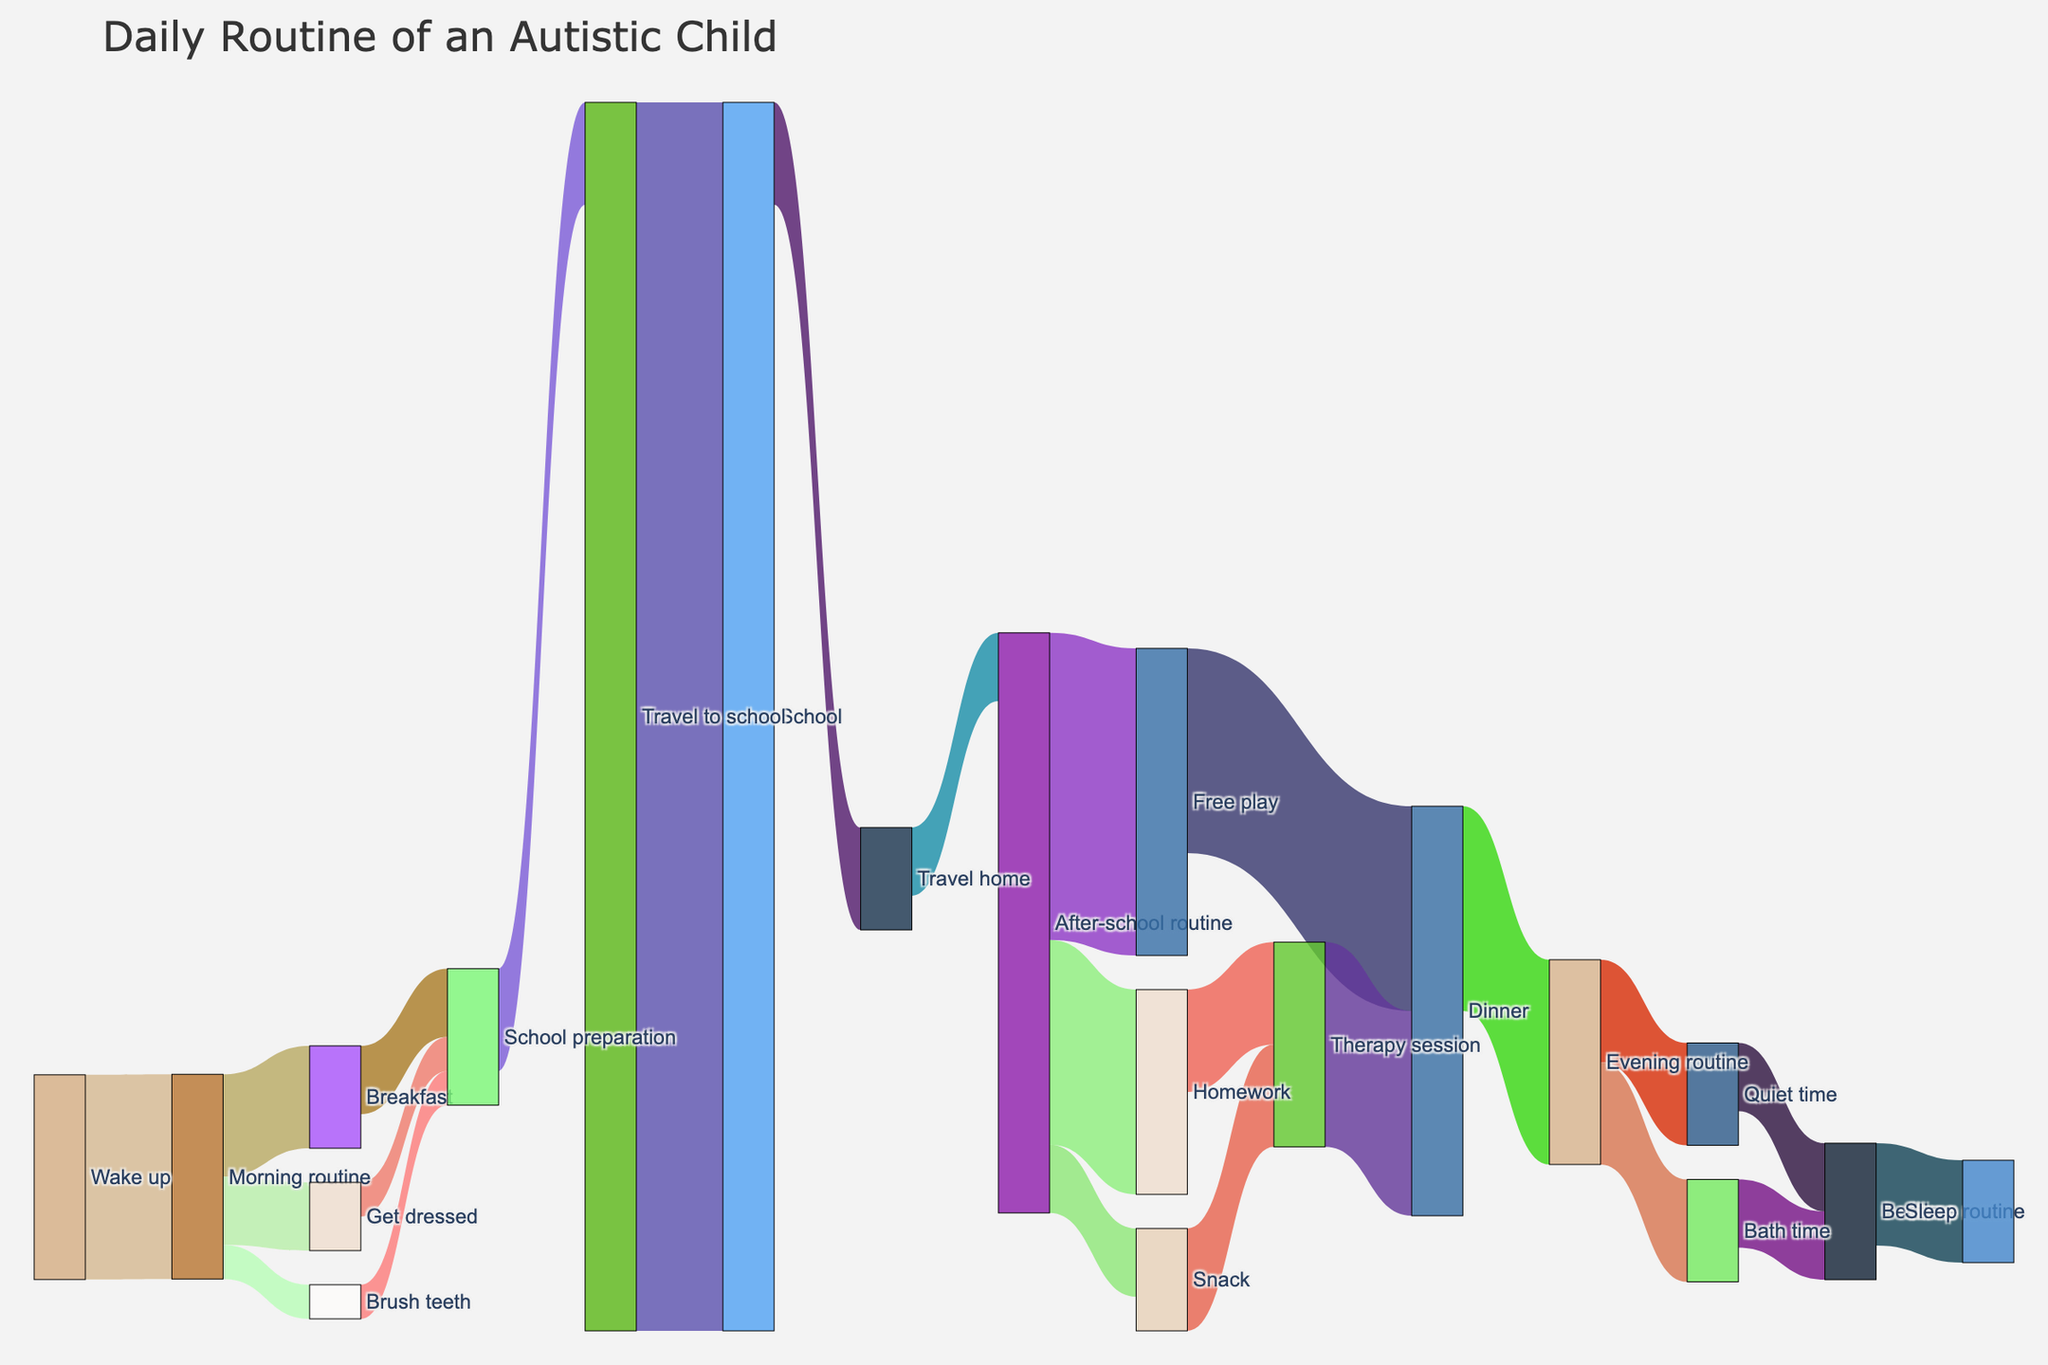What is the title of the figure? The title is at the top of the figure and provides an overview of what the figure represents.
Answer: Daily Routine of an Autistic Child How long is the duration of the Therapy session, and which activities transition into it? By observing the connections and the values indicated, you can see the activities and their corresponding time leading into the Therapy session.
Answer: Therapy session is 30 minutes, transitioning from Snack and Homework From which activity does 'Travel to school' originate and how long does it take? The diagram shows that 'Travel to school' originates from 'School preparation' with a specific time value.
Answer: 'Travel to school' originates from 'School preparation' and takes 30 minutes What is the total time spent on the Morning routine, including its breakdown? To find the total, sum the values of the individual activities within the Morning routine.
Answer: Total is 60 minutes, broken down into Breakfast (30), Get dressed (20), Brush teeth (10) How long does the Bath time take, and into which activity does it flow? The figure shows Bath time and provides the duration and its subsequent activity.
Answer: Bath time takes 30 minutes and flows into Bedtime routine Which activities form part of the Evening routine, and what is their total duration? By checking the connections from the Evening routine, you can track the activities and their times, then sum them up.
Answer: Bath time (30) and Quiet time (30), totaling 60 minutes Among ‘Homework’ and ‘Free play’, which activity has a longer duration and by how much? Compare the duration values of both activities as represented in the diagram and calculate the difference.
Answer: Free play is longer by 30 minutes (90 - 60) What activities occur between ‘Wake up’ and ‘Travel to school’? Trace the sequence of activities and their transitions from ‘Wake up’ to ‘Travel to school’.
Answer: Morning routine -> Breakfast/Get dressed/Brush teeth -> School preparation -> Travel to school After ‘Dinner’, what activities are engaged in and for how long? Follow the sequence from ‘Dinner’ and note the durations for each subsequent activity.
Answer: Evening routine (60), leading to Bath time (30) and Quiet time (30) How much time is allocated for ‘School’ and what is the next activity? The duration and subsequent activity for 'School' are indicated in the diagram.
Answer: School lasts for 360 minutes, followed by Travel home 